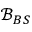Convert formula to latex. <formula><loc_0><loc_0><loc_500><loc_500>\mathcal { B } _ { B S }</formula> 